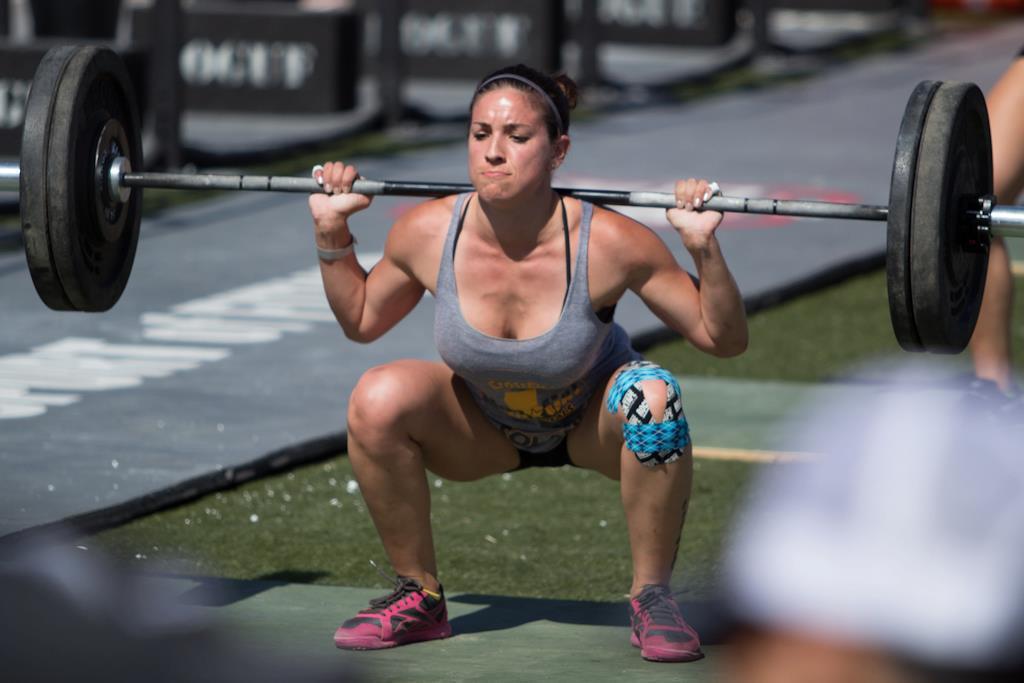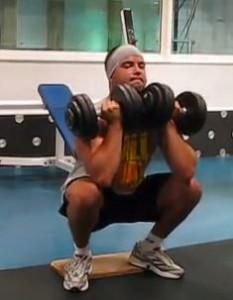The first image is the image on the left, the second image is the image on the right. Assess this claim about the two images: "A woman is lifting weights in a squat position.". Correct or not? Answer yes or no. Yes. The first image is the image on the left, the second image is the image on the right. Evaluate the accuracy of this statement regarding the images: "A single person is lifting weights in each of the images.". Is it true? Answer yes or no. Yes. 